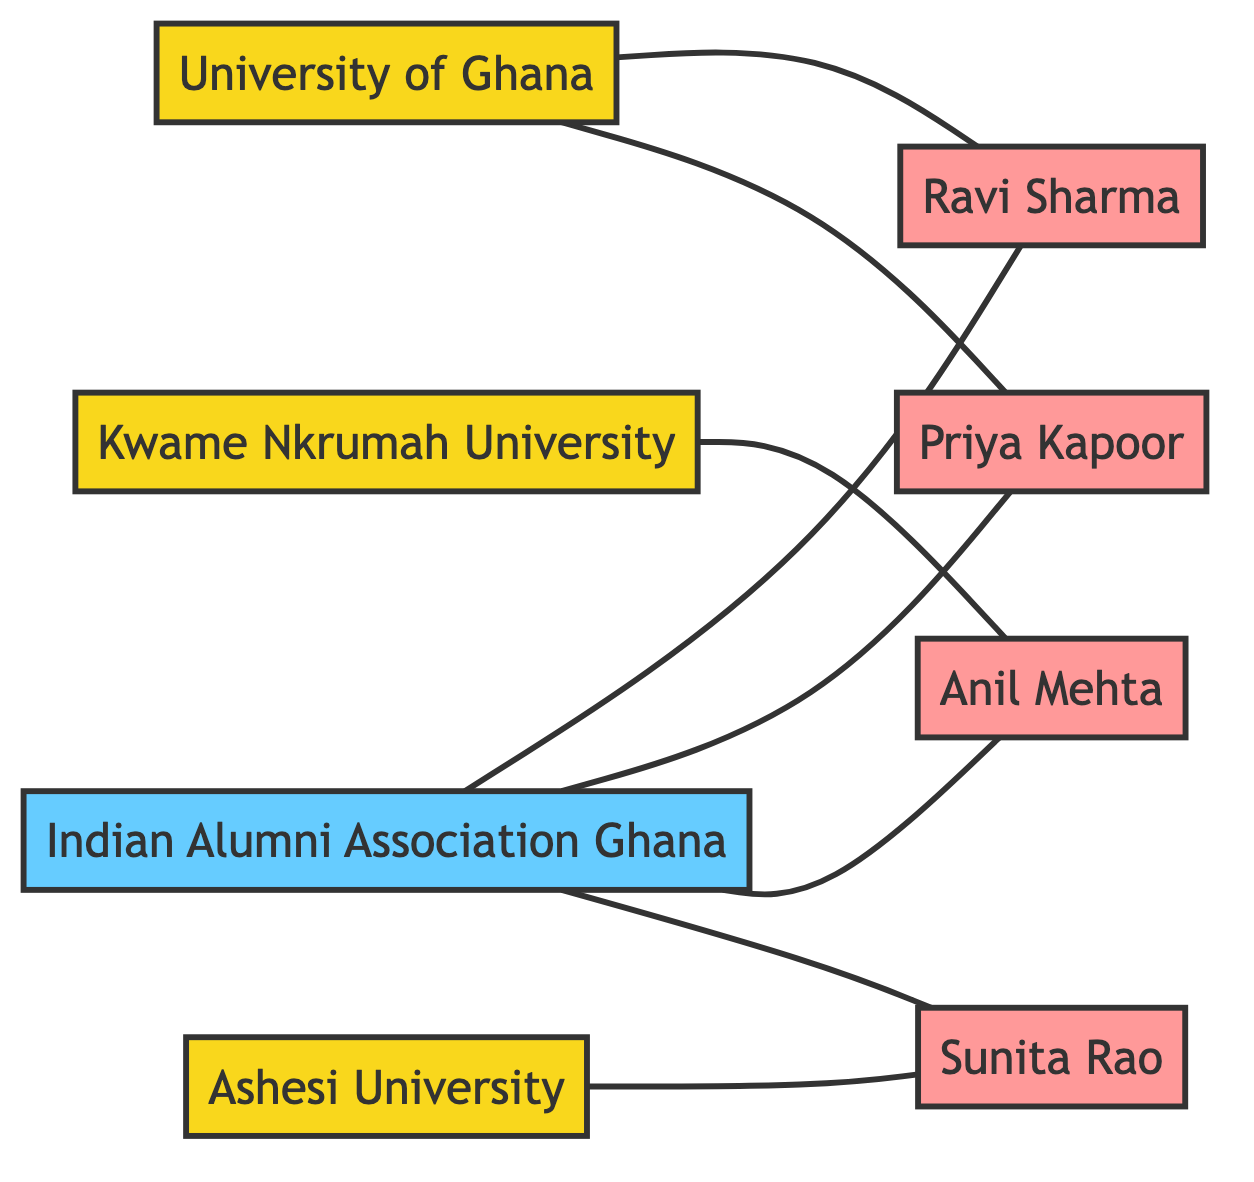What is the total number of nodes in the diagram? The diagram contains 8 nodes, which include 3 universities, 1 Indian Alumni Association, and 4 individual alumni.
Answer: 8 How many edges are connected to the Indian Alumni Association Ghana? The Indian Alumni Association Ghana has 4 edges connecting it to the individual alumni: Ravi Sharma, Priya Kapoor, Anil Mehta, and Sunita Rao.
Answer: 4 Which university is connected to Ravi Sharma? Ravi Sharma is connected to the University of Ghana, as indicated by the edge linking them.
Answer: University of Ghana List all individual alumni connected to Kwame Nkrumah University of Science and Technology. Anil Mehta is the only individual alumni connected to Kwame Nkrumah University of Science and Technology.
Answer: Anil Mehta Which university has the most connections with alumni? The Indian Alumni Association Ghana has connections with all four individual alumni, making it the university with the most connections.
Answer: Indian Alumni Association Ghana Are there any direct connections between the universities? There are no direct connections (edges) between the universities themselves, as they only connect to alumni and the association.
Answer: No Which alumni are connected to Ashesi University? Sunita Rao is the only alumni connected to Ashesi University based on the edges in the diagram.
Answer: Sunita Rao Which Indian alumni are connected to the University of Ghana? Ravi Sharma and Priya Kapoor are both connected to the University of Ghana according to the edges.
Answer: Ravi Sharma, Priya Kapoor How many universities are represented in the diagram? There are 3 universities represented: University of Ghana, Kwame Nkrumah University of Science and Technology, and Ashesi University.
Answer: 3 